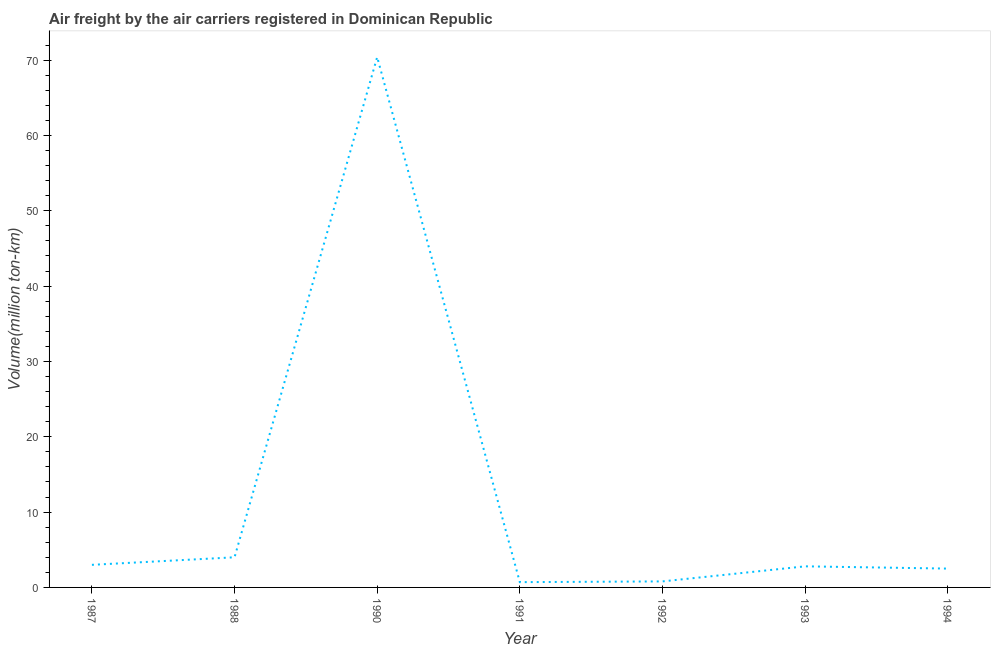What is the air freight in 1992?
Give a very brief answer. 0.8. Across all years, what is the maximum air freight?
Your response must be concise. 70.4. Across all years, what is the minimum air freight?
Offer a very short reply. 0.7. In which year was the air freight maximum?
Make the answer very short. 1990. What is the sum of the air freight?
Give a very brief answer. 84.2. What is the difference between the air freight in 1987 and 1992?
Your answer should be compact. 2.2. What is the average air freight per year?
Offer a terse response. 12.03. What is the median air freight?
Keep it short and to the point. 2.8. In how many years, is the air freight greater than 14 million ton-km?
Offer a very short reply. 1. Do a majority of the years between 1990 and 1991 (inclusive) have air freight greater than 50 million ton-km?
Your answer should be very brief. No. What is the ratio of the air freight in 1991 to that in 1993?
Ensure brevity in your answer.  0.25. Is the difference between the air freight in 1992 and 1993 greater than the difference between any two years?
Keep it short and to the point. No. What is the difference between the highest and the second highest air freight?
Offer a very short reply. 66.4. What is the difference between the highest and the lowest air freight?
Ensure brevity in your answer.  69.7. Does the air freight monotonically increase over the years?
Provide a succinct answer. No. How many lines are there?
Provide a short and direct response. 1. What is the difference between two consecutive major ticks on the Y-axis?
Offer a terse response. 10. Does the graph contain grids?
Make the answer very short. No. What is the title of the graph?
Provide a short and direct response. Air freight by the air carriers registered in Dominican Republic. What is the label or title of the Y-axis?
Ensure brevity in your answer.  Volume(million ton-km). What is the Volume(million ton-km) in 1988?
Provide a short and direct response. 4. What is the Volume(million ton-km) in 1990?
Make the answer very short. 70.4. What is the Volume(million ton-km) of 1991?
Give a very brief answer. 0.7. What is the Volume(million ton-km) of 1992?
Provide a short and direct response. 0.8. What is the Volume(million ton-km) in 1993?
Provide a succinct answer. 2.8. What is the Volume(million ton-km) in 1994?
Provide a short and direct response. 2.5. What is the difference between the Volume(million ton-km) in 1987 and 1990?
Provide a short and direct response. -67.4. What is the difference between the Volume(million ton-km) in 1987 and 1993?
Make the answer very short. 0.2. What is the difference between the Volume(million ton-km) in 1987 and 1994?
Provide a succinct answer. 0.5. What is the difference between the Volume(million ton-km) in 1988 and 1990?
Provide a succinct answer. -66.4. What is the difference between the Volume(million ton-km) in 1988 and 1992?
Offer a very short reply. 3.2. What is the difference between the Volume(million ton-km) in 1988 and 1994?
Your response must be concise. 1.5. What is the difference between the Volume(million ton-km) in 1990 and 1991?
Make the answer very short. 69.7. What is the difference between the Volume(million ton-km) in 1990 and 1992?
Your answer should be very brief. 69.6. What is the difference between the Volume(million ton-km) in 1990 and 1993?
Give a very brief answer. 67.6. What is the difference between the Volume(million ton-km) in 1990 and 1994?
Offer a terse response. 67.9. What is the difference between the Volume(million ton-km) in 1992 and 1994?
Offer a very short reply. -1.7. What is the ratio of the Volume(million ton-km) in 1987 to that in 1990?
Your answer should be very brief. 0.04. What is the ratio of the Volume(million ton-km) in 1987 to that in 1991?
Provide a short and direct response. 4.29. What is the ratio of the Volume(million ton-km) in 1987 to that in 1992?
Your answer should be compact. 3.75. What is the ratio of the Volume(million ton-km) in 1987 to that in 1993?
Ensure brevity in your answer.  1.07. What is the ratio of the Volume(million ton-km) in 1988 to that in 1990?
Provide a short and direct response. 0.06. What is the ratio of the Volume(million ton-km) in 1988 to that in 1991?
Provide a short and direct response. 5.71. What is the ratio of the Volume(million ton-km) in 1988 to that in 1993?
Ensure brevity in your answer.  1.43. What is the ratio of the Volume(million ton-km) in 1988 to that in 1994?
Your response must be concise. 1.6. What is the ratio of the Volume(million ton-km) in 1990 to that in 1991?
Keep it short and to the point. 100.57. What is the ratio of the Volume(million ton-km) in 1990 to that in 1993?
Keep it short and to the point. 25.14. What is the ratio of the Volume(million ton-km) in 1990 to that in 1994?
Ensure brevity in your answer.  28.16. What is the ratio of the Volume(million ton-km) in 1991 to that in 1992?
Keep it short and to the point. 0.88. What is the ratio of the Volume(million ton-km) in 1991 to that in 1994?
Make the answer very short. 0.28. What is the ratio of the Volume(million ton-km) in 1992 to that in 1993?
Give a very brief answer. 0.29. What is the ratio of the Volume(million ton-km) in 1992 to that in 1994?
Your answer should be very brief. 0.32. What is the ratio of the Volume(million ton-km) in 1993 to that in 1994?
Your answer should be very brief. 1.12. 